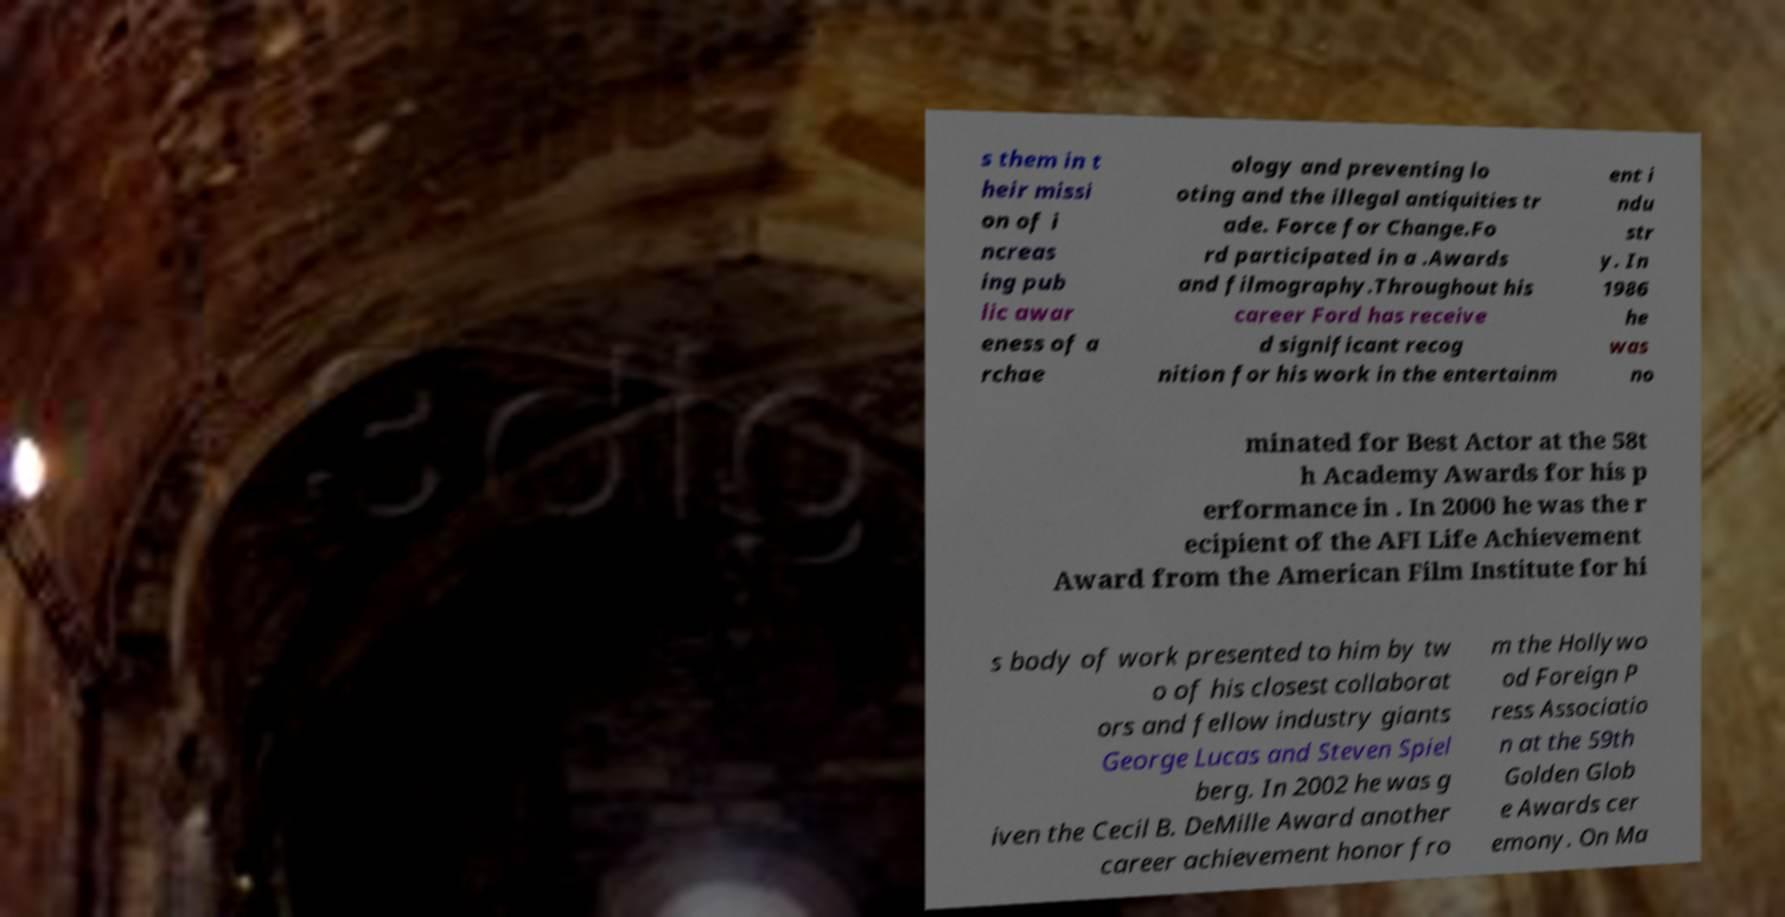I need the written content from this picture converted into text. Can you do that? s them in t heir missi on of i ncreas ing pub lic awar eness of a rchae ology and preventing lo oting and the illegal antiquities tr ade. Force for Change.Fo rd participated in a .Awards and filmography.Throughout his career Ford has receive d significant recog nition for his work in the entertainm ent i ndu str y. In 1986 he was no minated for Best Actor at the 58t h Academy Awards for his p erformance in . In 2000 he was the r ecipient of the AFI Life Achievement Award from the American Film Institute for hi s body of work presented to him by tw o of his closest collaborat ors and fellow industry giants George Lucas and Steven Spiel berg. In 2002 he was g iven the Cecil B. DeMille Award another career achievement honor fro m the Hollywo od Foreign P ress Associatio n at the 59th Golden Glob e Awards cer emony. On Ma 